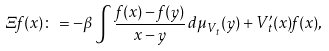<formula> <loc_0><loc_0><loc_500><loc_500>\Xi f ( x ) \colon = - \beta \int \frac { f ( x ) - f ( y ) } { x - y } \, d \mu _ { V _ { t } } ( y ) + V ^ { \prime } _ { t } ( x ) f ( x ) ,</formula> 